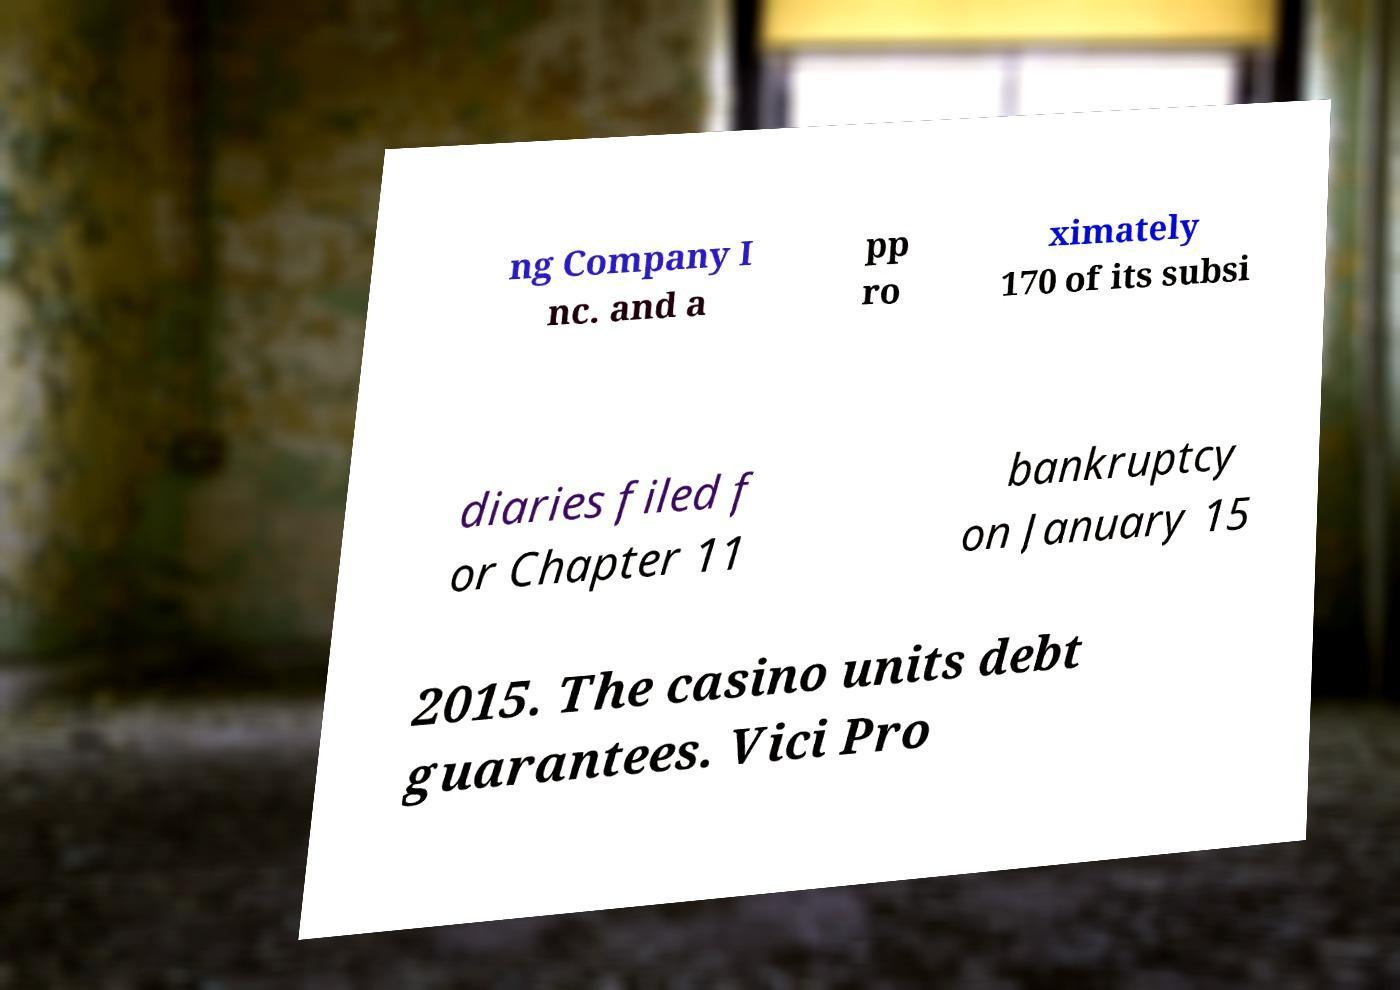Can you accurately transcribe the text from the provided image for me? ng Company I nc. and a pp ro ximately 170 of its subsi diaries filed f or Chapter 11 bankruptcy on January 15 2015. The casino units debt guarantees. Vici Pro 